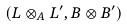Convert formula to latex. <formula><loc_0><loc_0><loc_500><loc_500>( L \otimes _ { A } L ^ { \prime } , B \otimes B ^ { \prime } )</formula> 